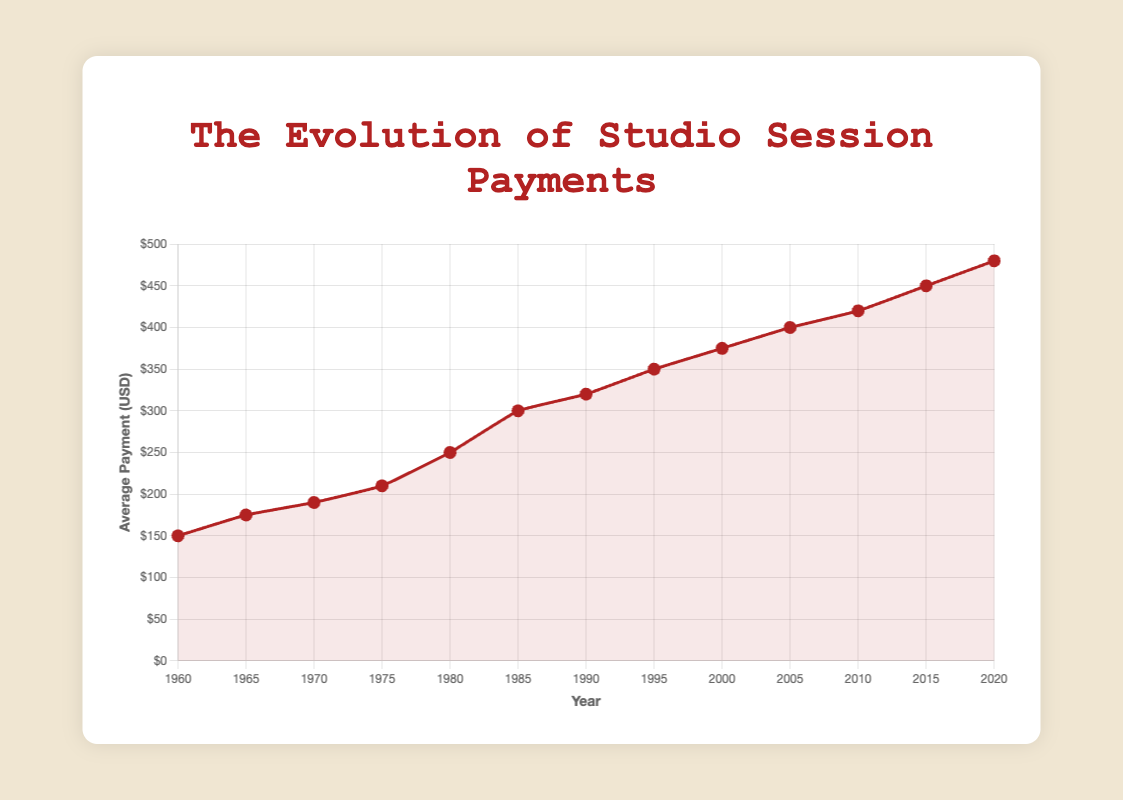Which year had the highest average payment per session? To find the year with the highest average payment per session, look at the data points and identify the year corresponding to the peak value on the graph. The highest average payment per session is $480, occurring in the year 2020.
Answer: 2020 What was the average payment per session in 1970 compared to 2020? Look at the values for the years 1970 and 2020 on the graph. In 1970, the payment was $190, and in 2020, it was $480.
Answer: 1970: $190, 2020: $480 How much more was the average payment per session in 1985 compared to 1965? Locate the values for 1985 and 1965 on the graph. In 1985, the payment was $300, and in 1965, it was $175. Subtract the 1965 value from the 1985 value: $300 - $175 = $125.
Answer: $125 What is the total increase in average payment per session from 1960 to 2020? Identify the values for 1960 and 2020. The value for 1960 is $150, and for 2020, it's $480. Subtract the 1960 value from the 2020 value: $480 - $150 = $330.
Answer: $330 Between which consecutive years was the biggest increase in average payment per session? Calculate the increase for each consecutive period: 
1960-1965 = $175 - $150 = $25
1965-1970 = $190 - $175 = $15
1970-1975 = $210 - $190 = $20
1975-1980 = $250 - $210 = $40
1980-1985 = $300 - $250 = $50
1985-1990 = $320 - $300 = $20
1990-1995 = $350 - $320 = $30
1995-2000 = $375 - $350 = $25
2000-2005 = $400 - $375 = $25
2005-2010 = $420 - $400 = $20
2010-2015 = $450 - $420 = $30
2015-2020 = $480 - $450 = $30
The period with the biggest increase is from 1980 to 1985 with an increase of $50.
Answer: 1980-1985 What was the average payment per session in 1985 and how does it visually compare to the payment in 2010 on the graph? The average payment in 1985 was $300, marked with the red point. In 2010, the payment was $420, marked higher than the 1985 point, indicating an increase.
Answer: 1985: $300, 2010: $420 Calculate the compound annual growth rate (CAGR) of the average payment per session from 1960 to 2020. CAGR can be calculated using the formula CAGR = (Ending Value / Beginning Value) ^ (1 / Number of Periods) - 1. Plugging in the values: 
CAGR = ($480 / $150) ^ (1 / 60) - 1 ≈ 0.0174 or 1.74%.
Answer: 1.74% By how much did the average payment per session increase from 1990 to 2015? Identify the values for 1990 ($320) and 2015 ($450). Subtract the 1990 value from the 2015 value: $450 - $320 = $130.
Answer: $130 What was the average payment per session 10 years after 1970, and how did it compare to the value 10 years prior? The average payment per session 10 years after 1970 (i.e., 1980) was $250, and 10 years prior (i.e., 1960) was $150. Thus, it increased by $100 over those 20 years.
Answer: Increased by $100 